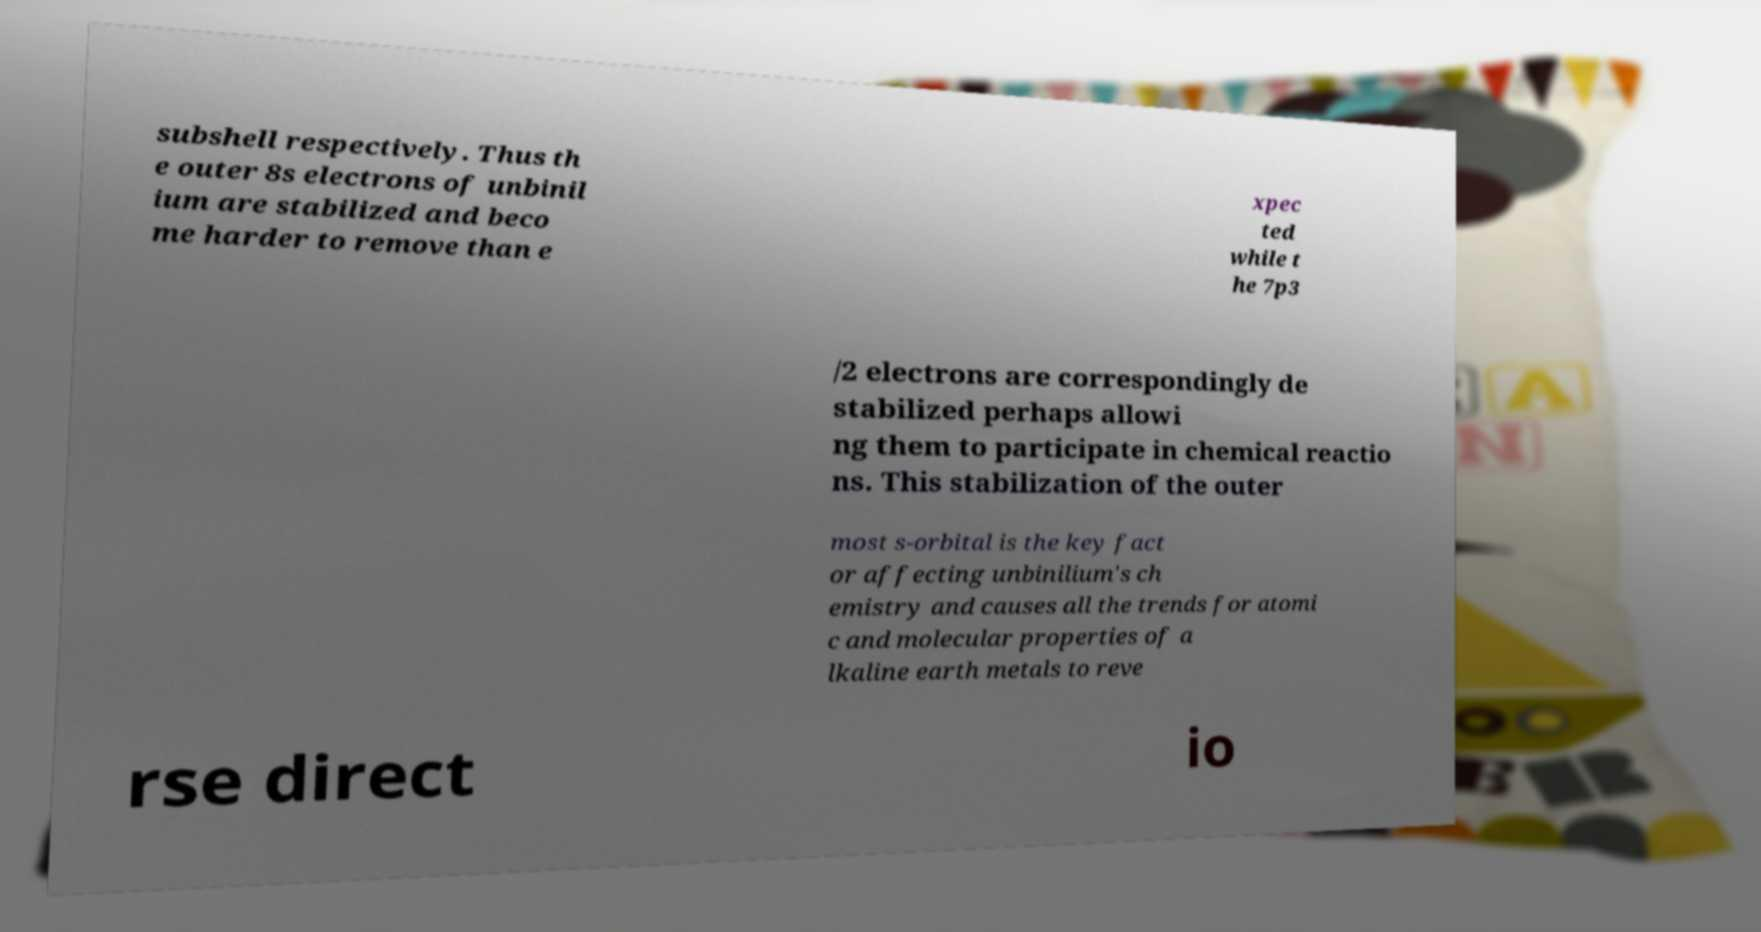Could you assist in decoding the text presented in this image and type it out clearly? subshell respectively. Thus th e outer 8s electrons of unbinil ium are stabilized and beco me harder to remove than e xpec ted while t he 7p3 /2 electrons are correspondingly de stabilized perhaps allowi ng them to participate in chemical reactio ns. This stabilization of the outer most s-orbital is the key fact or affecting unbinilium's ch emistry and causes all the trends for atomi c and molecular properties of a lkaline earth metals to reve rse direct io 